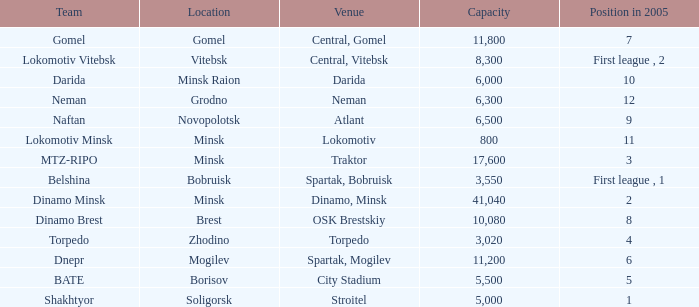Can you tell me the Venue that has the Position in 2005 of 8? OSK Brestskiy. 